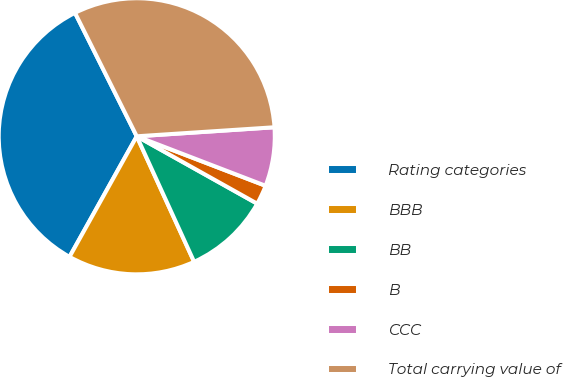<chart> <loc_0><loc_0><loc_500><loc_500><pie_chart><fcel>Rating categories<fcel>BBB<fcel>BB<fcel>B<fcel>CCC<fcel>Total carrying value of<nl><fcel>34.52%<fcel>14.92%<fcel>10.06%<fcel>2.28%<fcel>6.88%<fcel>31.34%<nl></chart> 